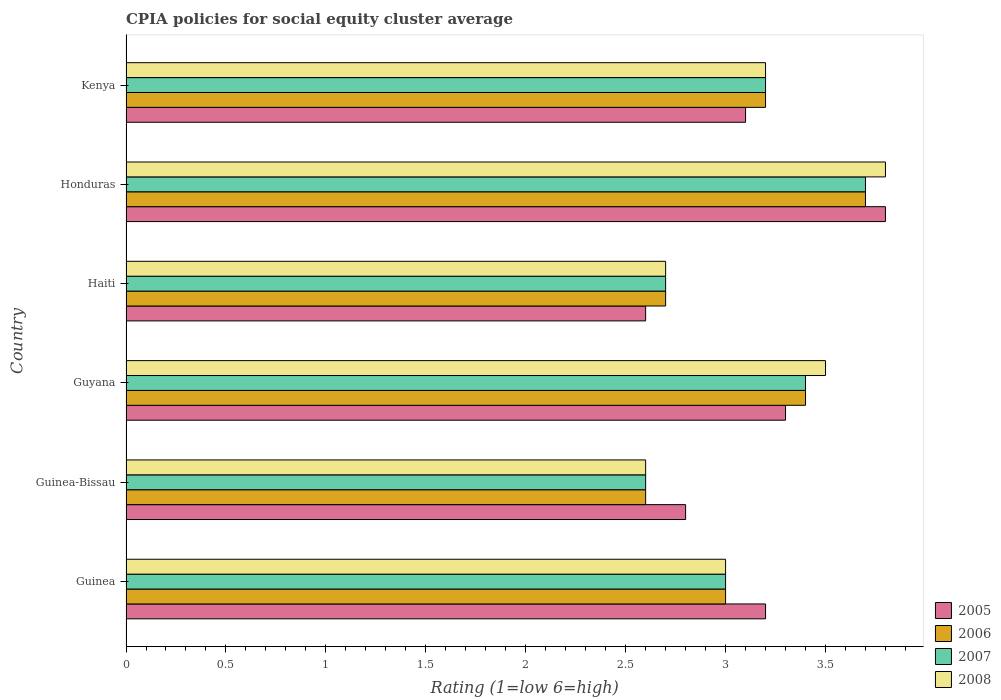How many different coloured bars are there?
Your response must be concise. 4. How many bars are there on the 5th tick from the bottom?
Ensure brevity in your answer.  4. What is the label of the 6th group of bars from the top?
Provide a succinct answer. Guinea. In how many cases, is the number of bars for a given country not equal to the number of legend labels?
Offer a terse response. 0. What is the CPIA rating in 2007 in Guinea?
Keep it short and to the point. 3. Across all countries, what is the maximum CPIA rating in 2006?
Your answer should be very brief. 3.7. Across all countries, what is the minimum CPIA rating in 2007?
Provide a succinct answer. 2.6. In which country was the CPIA rating in 2005 maximum?
Offer a terse response. Honduras. In which country was the CPIA rating in 2006 minimum?
Keep it short and to the point. Guinea-Bissau. What is the total CPIA rating in 2008 in the graph?
Make the answer very short. 18.8. What is the difference between the CPIA rating in 2005 in Guyana and that in Kenya?
Give a very brief answer. 0.2. What is the difference between the CPIA rating in 2006 in Guinea-Bissau and the CPIA rating in 2007 in Haiti?
Your answer should be compact. -0.1. What is the average CPIA rating in 2006 per country?
Make the answer very short. 3.1. In how many countries, is the CPIA rating in 2008 greater than 3 ?
Offer a terse response. 3. What is the ratio of the CPIA rating in 2006 in Guyana to that in Kenya?
Provide a short and direct response. 1.06. Is the CPIA rating in 2005 in Guinea-Bissau less than that in Honduras?
Make the answer very short. Yes. Is the difference between the CPIA rating in 2006 in Guinea and Haiti greater than the difference between the CPIA rating in 2007 in Guinea and Haiti?
Provide a succinct answer. No. What is the difference between the highest and the second highest CPIA rating in 2007?
Ensure brevity in your answer.  0.3. What is the difference between the highest and the lowest CPIA rating in 2005?
Give a very brief answer. 1.2. In how many countries, is the CPIA rating in 2005 greater than the average CPIA rating in 2005 taken over all countries?
Offer a very short reply. 3. What does the 4th bar from the top in Honduras represents?
Offer a very short reply. 2005. What does the 4th bar from the bottom in Honduras represents?
Keep it short and to the point. 2008. Is it the case that in every country, the sum of the CPIA rating in 2006 and CPIA rating in 2005 is greater than the CPIA rating in 2008?
Give a very brief answer. Yes. What is the difference between two consecutive major ticks on the X-axis?
Keep it short and to the point. 0.5. What is the title of the graph?
Your response must be concise. CPIA policies for social equity cluster average. What is the label or title of the Y-axis?
Provide a succinct answer. Country. What is the Rating (1=low 6=high) of 2006 in Guinea?
Offer a very short reply. 3. What is the Rating (1=low 6=high) of 2008 in Guinea?
Give a very brief answer. 3. What is the Rating (1=low 6=high) of 2008 in Guinea-Bissau?
Your answer should be compact. 2.6. What is the Rating (1=low 6=high) in 2006 in Guyana?
Your answer should be compact. 3.4. What is the Rating (1=low 6=high) of 2008 in Guyana?
Your answer should be compact. 3.5. What is the Rating (1=low 6=high) of 2006 in Haiti?
Provide a short and direct response. 2.7. What is the Rating (1=low 6=high) of 2008 in Haiti?
Provide a succinct answer. 2.7. What is the Rating (1=low 6=high) of 2008 in Honduras?
Give a very brief answer. 3.8. What is the Rating (1=low 6=high) in 2005 in Kenya?
Make the answer very short. 3.1. What is the Rating (1=low 6=high) in 2006 in Kenya?
Provide a succinct answer. 3.2. What is the Rating (1=low 6=high) in 2007 in Kenya?
Provide a succinct answer. 3.2. What is the Rating (1=low 6=high) in 2008 in Kenya?
Offer a terse response. 3.2. Across all countries, what is the maximum Rating (1=low 6=high) in 2007?
Your answer should be compact. 3.7. Across all countries, what is the minimum Rating (1=low 6=high) of 2008?
Provide a succinct answer. 2.6. What is the total Rating (1=low 6=high) of 2005 in the graph?
Provide a succinct answer. 18.8. What is the total Rating (1=low 6=high) in 2006 in the graph?
Provide a succinct answer. 18.6. What is the total Rating (1=low 6=high) of 2007 in the graph?
Offer a very short reply. 18.6. What is the difference between the Rating (1=low 6=high) of 2007 in Guinea and that in Guinea-Bissau?
Provide a short and direct response. 0.4. What is the difference between the Rating (1=low 6=high) of 2008 in Guinea and that in Guinea-Bissau?
Ensure brevity in your answer.  0.4. What is the difference between the Rating (1=low 6=high) in 2007 in Guinea and that in Guyana?
Make the answer very short. -0.4. What is the difference between the Rating (1=low 6=high) of 2008 in Guinea and that in Guyana?
Your answer should be compact. -0.5. What is the difference between the Rating (1=low 6=high) of 2006 in Guinea and that in Haiti?
Make the answer very short. 0.3. What is the difference between the Rating (1=low 6=high) of 2008 in Guinea and that in Haiti?
Provide a succinct answer. 0.3. What is the difference between the Rating (1=low 6=high) in 2005 in Guinea and that in Honduras?
Your answer should be very brief. -0.6. What is the difference between the Rating (1=low 6=high) of 2005 in Guinea and that in Kenya?
Offer a very short reply. 0.1. What is the difference between the Rating (1=low 6=high) in 2006 in Guinea and that in Kenya?
Provide a succinct answer. -0.2. What is the difference between the Rating (1=low 6=high) in 2006 in Guinea-Bissau and that in Guyana?
Offer a terse response. -0.8. What is the difference between the Rating (1=low 6=high) of 2007 in Guinea-Bissau and that in Guyana?
Your answer should be very brief. -0.8. What is the difference between the Rating (1=low 6=high) in 2005 in Guinea-Bissau and that in Haiti?
Offer a terse response. 0.2. What is the difference between the Rating (1=low 6=high) of 2008 in Guinea-Bissau and that in Honduras?
Your response must be concise. -1.2. What is the difference between the Rating (1=low 6=high) in 2005 in Guinea-Bissau and that in Kenya?
Make the answer very short. -0.3. What is the difference between the Rating (1=low 6=high) in 2006 in Guinea-Bissau and that in Kenya?
Your response must be concise. -0.6. What is the difference between the Rating (1=low 6=high) in 2007 in Guinea-Bissau and that in Kenya?
Make the answer very short. -0.6. What is the difference between the Rating (1=low 6=high) of 2005 in Guyana and that in Haiti?
Your answer should be compact. 0.7. What is the difference between the Rating (1=low 6=high) of 2006 in Guyana and that in Honduras?
Give a very brief answer. -0.3. What is the difference between the Rating (1=low 6=high) in 2008 in Guyana and that in Honduras?
Ensure brevity in your answer.  -0.3. What is the difference between the Rating (1=low 6=high) of 2006 in Guyana and that in Kenya?
Provide a succinct answer. 0.2. What is the difference between the Rating (1=low 6=high) in 2008 in Guyana and that in Kenya?
Offer a terse response. 0.3. What is the difference between the Rating (1=low 6=high) in 2005 in Haiti and that in Honduras?
Provide a short and direct response. -1.2. What is the difference between the Rating (1=low 6=high) of 2006 in Haiti and that in Honduras?
Offer a terse response. -1. What is the difference between the Rating (1=low 6=high) in 2007 in Haiti and that in Honduras?
Give a very brief answer. -1. What is the difference between the Rating (1=low 6=high) in 2005 in Guinea and the Rating (1=low 6=high) in 2006 in Guinea-Bissau?
Offer a terse response. 0.6. What is the difference between the Rating (1=low 6=high) of 2005 in Guinea and the Rating (1=low 6=high) of 2007 in Guinea-Bissau?
Ensure brevity in your answer.  0.6. What is the difference between the Rating (1=low 6=high) of 2005 in Guinea and the Rating (1=low 6=high) of 2008 in Guinea-Bissau?
Provide a short and direct response. 0.6. What is the difference between the Rating (1=low 6=high) in 2006 in Guinea and the Rating (1=low 6=high) in 2008 in Guinea-Bissau?
Offer a very short reply. 0.4. What is the difference between the Rating (1=low 6=high) of 2005 in Guinea and the Rating (1=low 6=high) of 2007 in Guyana?
Provide a short and direct response. -0.2. What is the difference between the Rating (1=low 6=high) in 2005 in Guinea and the Rating (1=low 6=high) in 2007 in Haiti?
Offer a very short reply. 0.5. What is the difference between the Rating (1=low 6=high) in 2005 in Guinea and the Rating (1=low 6=high) in 2008 in Haiti?
Provide a short and direct response. 0.5. What is the difference between the Rating (1=low 6=high) of 2005 in Guinea and the Rating (1=low 6=high) of 2006 in Honduras?
Your answer should be compact. -0.5. What is the difference between the Rating (1=low 6=high) of 2005 in Guinea and the Rating (1=low 6=high) of 2007 in Honduras?
Provide a succinct answer. -0.5. What is the difference between the Rating (1=low 6=high) in 2007 in Guinea and the Rating (1=low 6=high) in 2008 in Honduras?
Keep it short and to the point. -0.8. What is the difference between the Rating (1=low 6=high) of 2005 in Guinea and the Rating (1=low 6=high) of 2007 in Kenya?
Your answer should be very brief. 0. What is the difference between the Rating (1=low 6=high) in 2006 in Guinea and the Rating (1=low 6=high) in 2007 in Kenya?
Provide a succinct answer. -0.2. What is the difference between the Rating (1=low 6=high) in 2005 in Guinea-Bissau and the Rating (1=low 6=high) in 2007 in Guyana?
Keep it short and to the point. -0.6. What is the difference between the Rating (1=low 6=high) in 2005 in Guinea-Bissau and the Rating (1=low 6=high) in 2008 in Guyana?
Your answer should be very brief. -0.7. What is the difference between the Rating (1=low 6=high) in 2006 in Guinea-Bissau and the Rating (1=low 6=high) in 2008 in Guyana?
Provide a short and direct response. -0.9. What is the difference between the Rating (1=low 6=high) in 2005 in Guinea-Bissau and the Rating (1=low 6=high) in 2008 in Haiti?
Your answer should be very brief. 0.1. What is the difference between the Rating (1=low 6=high) in 2006 in Guinea-Bissau and the Rating (1=low 6=high) in 2008 in Haiti?
Offer a terse response. -0.1. What is the difference between the Rating (1=low 6=high) in 2005 in Guinea-Bissau and the Rating (1=low 6=high) in 2007 in Honduras?
Offer a terse response. -0.9. What is the difference between the Rating (1=low 6=high) of 2005 in Guinea-Bissau and the Rating (1=low 6=high) of 2008 in Honduras?
Keep it short and to the point. -1. What is the difference between the Rating (1=low 6=high) in 2006 in Guinea-Bissau and the Rating (1=low 6=high) in 2008 in Honduras?
Your response must be concise. -1.2. What is the difference between the Rating (1=low 6=high) in 2005 in Guinea-Bissau and the Rating (1=low 6=high) in 2007 in Kenya?
Make the answer very short. -0.4. What is the difference between the Rating (1=low 6=high) in 2005 in Guinea-Bissau and the Rating (1=low 6=high) in 2008 in Kenya?
Your answer should be very brief. -0.4. What is the difference between the Rating (1=low 6=high) in 2005 in Guyana and the Rating (1=low 6=high) in 2007 in Haiti?
Keep it short and to the point. 0.6. What is the difference between the Rating (1=low 6=high) of 2006 in Guyana and the Rating (1=low 6=high) of 2008 in Haiti?
Offer a very short reply. 0.7. What is the difference between the Rating (1=low 6=high) in 2007 in Guyana and the Rating (1=low 6=high) in 2008 in Haiti?
Your response must be concise. 0.7. What is the difference between the Rating (1=low 6=high) in 2005 in Guyana and the Rating (1=low 6=high) in 2008 in Honduras?
Ensure brevity in your answer.  -0.5. What is the difference between the Rating (1=low 6=high) of 2006 in Guyana and the Rating (1=low 6=high) of 2007 in Honduras?
Your answer should be very brief. -0.3. What is the difference between the Rating (1=low 6=high) of 2006 in Guyana and the Rating (1=low 6=high) of 2008 in Honduras?
Keep it short and to the point. -0.4. What is the difference between the Rating (1=low 6=high) of 2007 in Guyana and the Rating (1=low 6=high) of 2008 in Honduras?
Keep it short and to the point. -0.4. What is the difference between the Rating (1=low 6=high) in 2005 in Guyana and the Rating (1=low 6=high) in 2006 in Kenya?
Make the answer very short. 0.1. What is the difference between the Rating (1=low 6=high) in 2005 in Guyana and the Rating (1=low 6=high) in 2007 in Kenya?
Keep it short and to the point. 0.1. What is the difference between the Rating (1=low 6=high) in 2005 in Guyana and the Rating (1=low 6=high) in 2008 in Kenya?
Keep it short and to the point. 0.1. What is the difference between the Rating (1=low 6=high) in 2006 in Guyana and the Rating (1=low 6=high) in 2007 in Kenya?
Your answer should be compact. 0.2. What is the difference between the Rating (1=low 6=high) in 2007 in Guyana and the Rating (1=low 6=high) in 2008 in Kenya?
Keep it short and to the point. 0.2. What is the difference between the Rating (1=low 6=high) in 2005 in Haiti and the Rating (1=low 6=high) in 2007 in Honduras?
Your response must be concise. -1.1. What is the difference between the Rating (1=low 6=high) of 2005 in Haiti and the Rating (1=low 6=high) of 2006 in Kenya?
Give a very brief answer. -0.6. What is the difference between the Rating (1=low 6=high) of 2006 in Haiti and the Rating (1=low 6=high) of 2007 in Kenya?
Your response must be concise. -0.5. What is the difference between the Rating (1=low 6=high) in 2006 in Haiti and the Rating (1=low 6=high) in 2008 in Kenya?
Make the answer very short. -0.5. What is the difference between the Rating (1=low 6=high) of 2007 in Haiti and the Rating (1=low 6=high) of 2008 in Kenya?
Make the answer very short. -0.5. What is the difference between the Rating (1=low 6=high) in 2005 in Honduras and the Rating (1=low 6=high) in 2006 in Kenya?
Offer a terse response. 0.6. What is the difference between the Rating (1=low 6=high) in 2005 in Honduras and the Rating (1=low 6=high) in 2007 in Kenya?
Give a very brief answer. 0.6. What is the difference between the Rating (1=low 6=high) of 2005 in Honduras and the Rating (1=low 6=high) of 2008 in Kenya?
Your response must be concise. 0.6. What is the difference between the Rating (1=low 6=high) in 2006 in Honduras and the Rating (1=low 6=high) in 2008 in Kenya?
Provide a succinct answer. 0.5. What is the difference between the Rating (1=low 6=high) of 2007 in Honduras and the Rating (1=low 6=high) of 2008 in Kenya?
Keep it short and to the point. 0.5. What is the average Rating (1=low 6=high) in 2005 per country?
Your answer should be very brief. 3.13. What is the average Rating (1=low 6=high) of 2006 per country?
Offer a terse response. 3.1. What is the average Rating (1=low 6=high) of 2008 per country?
Ensure brevity in your answer.  3.13. What is the difference between the Rating (1=low 6=high) of 2005 and Rating (1=low 6=high) of 2006 in Guinea?
Offer a very short reply. 0.2. What is the difference between the Rating (1=low 6=high) in 2006 and Rating (1=low 6=high) in 2008 in Guinea?
Provide a short and direct response. 0. What is the difference between the Rating (1=low 6=high) in 2005 and Rating (1=low 6=high) in 2008 in Guinea-Bissau?
Make the answer very short. 0.2. What is the difference between the Rating (1=low 6=high) of 2006 and Rating (1=low 6=high) of 2007 in Guinea-Bissau?
Give a very brief answer. 0. What is the difference between the Rating (1=low 6=high) in 2007 and Rating (1=low 6=high) in 2008 in Guinea-Bissau?
Your answer should be very brief. 0. What is the difference between the Rating (1=low 6=high) in 2005 and Rating (1=low 6=high) in 2006 in Guyana?
Offer a very short reply. -0.1. What is the difference between the Rating (1=low 6=high) of 2005 and Rating (1=low 6=high) of 2007 in Guyana?
Offer a terse response. -0.1. What is the difference between the Rating (1=low 6=high) of 2005 and Rating (1=low 6=high) of 2008 in Guyana?
Offer a very short reply. -0.2. What is the difference between the Rating (1=low 6=high) in 2006 and Rating (1=low 6=high) in 2007 in Guyana?
Provide a succinct answer. 0. What is the difference between the Rating (1=low 6=high) of 2006 and Rating (1=low 6=high) of 2008 in Guyana?
Make the answer very short. -0.1. What is the difference between the Rating (1=low 6=high) of 2005 and Rating (1=low 6=high) of 2006 in Haiti?
Give a very brief answer. -0.1. What is the difference between the Rating (1=low 6=high) in 2005 and Rating (1=low 6=high) in 2007 in Haiti?
Your answer should be very brief. -0.1. What is the difference between the Rating (1=low 6=high) of 2006 and Rating (1=low 6=high) of 2007 in Haiti?
Ensure brevity in your answer.  0. What is the difference between the Rating (1=low 6=high) of 2007 and Rating (1=low 6=high) of 2008 in Haiti?
Ensure brevity in your answer.  0. What is the difference between the Rating (1=low 6=high) in 2005 and Rating (1=low 6=high) in 2006 in Honduras?
Give a very brief answer. 0.1. What is the difference between the Rating (1=low 6=high) of 2005 and Rating (1=low 6=high) of 2008 in Honduras?
Your answer should be very brief. 0. What is the difference between the Rating (1=low 6=high) in 2006 and Rating (1=low 6=high) in 2007 in Honduras?
Your response must be concise. 0. What is the difference between the Rating (1=low 6=high) of 2006 and Rating (1=low 6=high) of 2008 in Honduras?
Your response must be concise. -0.1. What is the difference between the Rating (1=low 6=high) in 2005 and Rating (1=low 6=high) in 2006 in Kenya?
Offer a terse response. -0.1. What is the difference between the Rating (1=low 6=high) of 2005 and Rating (1=low 6=high) of 2007 in Kenya?
Provide a short and direct response. -0.1. What is the difference between the Rating (1=low 6=high) in 2006 and Rating (1=low 6=high) in 2008 in Kenya?
Give a very brief answer. 0. What is the difference between the Rating (1=low 6=high) of 2007 and Rating (1=low 6=high) of 2008 in Kenya?
Provide a short and direct response. 0. What is the ratio of the Rating (1=low 6=high) in 2006 in Guinea to that in Guinea-Bissau?
Ensure brevity in your answer.  1.15. What is the ratio of the Rating (1=low 6=high) in 2007 in Guinea to that in Guinea-Bissau?
Offer a very short reply. 1.15. What is the ratio of the Rating (1=low 6=high) of 2008 in Guinea to that in Guinea-Bissau?
Make the answer very short. 1.15. What is the ratio of the Rating (1=low 6=high) in 2005 in Guinea to that in Guyana?
Ensure brevity in your answer.  0.97. What is the ratio of the Rating (1=low 6=high) in 2006 in Guinea to that in Guyana?
Your answer should be compact. 0.88. What is the ratio of the Rating (1=low 6=high) in 2007 in Guinea to that in Guyana?
Give a very brief answer. 0.88. What is the ratio of the Rating (1=low 6=high) in 2008 in Guinea to that in Guyana?
Ensure brevity in your answer.  0.86. What is the ratio of the Rating (1=low 6=high) in 2005 in Guinea to that in Haiti?
Provide a succinct answer. 1.23. What is the ratio of the Rating (1=low 6=high) in 2006 in Guinea to that in Haiti?
Your answer should be compact. 1.11. What is the ratio of the Rating (1=low 6=high) of 2008 in Guinea to that in Haiti?
Make the answer very short. 1.11. What is the ratio of the Rating (1=low 6=high) in 2005 in Guinea to that in Honduras?
Ensure brevity in your answer.  0.84. What is the ratio of the Rating (1=low 6=high) of 2006 in Guinea to that in Honduras?
Ensure brevity in your answer.  0.81. What is the ratio of the Rating (1=low 6=high) in 2007 in Guinea to that in Honduras?
Your response must be concise. 0.81. What is the ratio of the Rating (1=low 6=high) of 2008 in Guinea to that in Honduras?
Your answer should be very brief. 0.79. What is the ratio of the Rating (1=low 6=high) in 2005 in Guinea to that in Kenya?
Your answer should be compact. 1.03. What is the ratio of the Rating (1=low 6=high) of 2007 in Guinea to that in Kenya?
Give a very brief answer. 0.94. What is the ratio of the Rating (1=low 6=high) in 2008 in Guinea to that in Kenya?
Give a very brief answer. 0.94. What is the ratio of the Rating (1=low 6=high) of 2005 in Guinea-Bissau to that in Guyana?
Keep it short and to the point. 0.85. What is the ratio of the Rating (1=low 6=high) in 2006 in Guinea-Bissau to that in Guyana?
Your answer should be very brief. 0.76. What is the ratio of the Rating (1=low 6=high) of 2007 in Guinea-Bissau to that in Guyana?
Your answer should be compact. 0.76. What is the ratio of the Rating (1=low 6=high) in 2008 in Guinea-Bissau to that in Guyana?
Provide a short and direct response. 0.74. What is the ratio of the Rating (1=low 6=high) of 2005 in Guinea-Bissau to that in Haiti?
Ensure brevity in your answer.  1.08. What is the ratio of the Rating (1=low 6=high) in 2006 in Guinea-Bissau to that in Haiti?
Give a very brief answer. 0.96. What is the ratio of the Rating (1=low 6=high) of 2005 in Guinea-Bissau to that in Honduras?
Provide a short and direct response. 0.74. What is the ratio of the Rating (1=low 6=high) in 2006 in Guinea-Bissau to that in Honduras?
Make the answer very short. 0.7. What is the ratio of the Rating (1=low 6=high) in 2007 in Guinea-Bissau to that in Honduras?
Your answer should be very brief. 0.7. What is the ratio of the Rating (1=low 6=high) of 2008 in Guinea-Bissau to that in Honduras?
Provide a succinct answer. 0.68. What is the ratio of the Rating (1=low 6=high) in 2005 in Guinea-Bissau to that in Kenya?
Give a very brief answer. 0.9. What is the ratio of the Rating (1=low 6=high) in 2006 in Guinea-Bissau to that in Kenya?
Your answer should be very brief. 0.81. What is the ratio of the Rating (1=low 6=high) in 2007 in Guinea-Bissau to that in Kenya?
Your answer should be compact. 0.81. What is the ratio of the Rating (1=low 6=high) of 2008 in Guinea-Bissau to that in Kenya?
Your answer should be compact. 0.81. What is the ratio of the Rating (1=low 6=high) of 2005 in Guyana to that in Haiti?
Offer a terse response. 1.27. What is the ratio of the Rating (1=low 6=high) of 2006 in Guyana to that in Haiti?
Give a very brief answer. 1.26. What is the ratio of the Rating (1=low 6=high) in 2007 in Guyana to that in Haiti?
Give a very brief answer. 1.26. What is the ratio of the Rating (1=low 6=high) in 2008 in Guyana to that in Haiti?
Ensure brevity in your answer.  1.3. What is the ratio of the Rating (1=low 6=high) of 2005 in Guyana to that in Honduras?
Make the answer very short. 0.87. What is the ratio of the Rating (1=low 6=high) of 2006 in Guyana to that in Honduras?
Your answer should be very brief. 0.92. What is the ratio of the Rating (1=low 6=high) of 2007 in Guyana to that in Honduras?
Your response must be concise. 0.92. What is the ratio of the Rating (1=low 6=high) of 2008 in Guyana to that in Honduras?
Your answer should be compact. 0.92. What is the ratio of the Rating (1=low 6=high) of 2005 in Guyana to that in Kenya?
Provide a succinct answer. 1.06. What is the ratio of the Rating (1=low 6=high) of 2006 in Guyana to that in Kenya?
Provide a short and direct response. 1.06. What is the ratio of the Rating (1=low 6=high) in 2007 in Guyana to that in Kenya?
Give a very brief answer. 1.06. What is the ratio of the Rating (1=low 6=high) in 2008 in Guyana to that in Kenya?
Keep it short and to the point. 1.09. What is the ratio of the Rating (1=low 6=high) in 2005 in Haiti to that in Honduras?
Offer a very short reply. 0.68. What is the ratio of the Rating (1=low 6=high) of 2006 in Haiti to that in Honduras?
Your answer should be compact. 0.73. What is the ratio of the Rating (1=low 6=high) of 2007 in Haiti to that in Honduras?
Give a very brief answer. 0.73. What is the ratio of the Rating (1=low 6=high) of 2008 in Haiti to that in Honduras?
Your response must be concise. 0.71. What is the ratio of the Rating (1=low 6=high) in 2005 in Haiti to that in Kenya?
Keep it short and to the point. 0.84. What is the ratio of the Rating (1=low 6=high) of 2006 in Haiti to that in Kenya?
Offer a very short reply. 0.84. What is the ratio of the Rating (1=low 6=high) of 2007 in Haiti to that in Kenya?
Provide a succinct answer. 0.84. What is the ratio of the Rating (1=low 6=high) in 2008 in Haiti to that in Kenya?
Ensure brevity in your answer.  0.84. What is the ratio of the Rating (1=low 6=high) of 2005 in Honduras to that in Kenya?
Provide a short and direct response. 1.23. What is the ratio of the Rating (1=low 6=high) in 2006 in Honduras to that in Kenya?
Provide a succinct answer. 1.16. What is the ratio of the Rating (1=low 6=high) in 2007 in Honduras to that in Kenya?
Provide a short and direct response. 1.16. What is the ratio of the Rating (1=low 6=high) in 2008 in Honduras to that in Kenya?
Provide a short and direct response. 1.19. What is the difference between the highest and the second highest Rating (1=low 6=high) in 2006?
Your answer should be very brief. 0.3. What is the difference between the highest and the second highest Rating (1=low 6=high) in 2007?
Give a very brief answer. 0.3. What is the difference between the highest and the second highest Rating (1=low 6=high) in 2008?
Your answer should be compact. 0.3. What is the difference between the highest and the lowest Rating (1=low 6=high) of 2007?
Your answer should be compact. 1.1. 